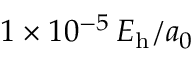<formula> <loc_0><loc_0><loc_500><loc_500>1 \times 1 0 ^ { - 5 } \, E _ { h } / a _ { 0 }</formula> 